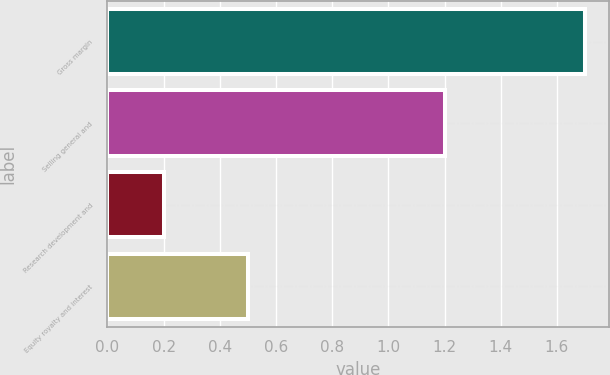Convert chart. <chart><loc_0><loc_0><loc_500><loc_500><bar_chart><fcel>Gross margin<fcel>Selling general and<fcel>Research development and<fcel>Equity royalty and interest<nl><fcel>1.7<fcel>1.2<fcel>0.2<fcel>0.5<nl></chart> 